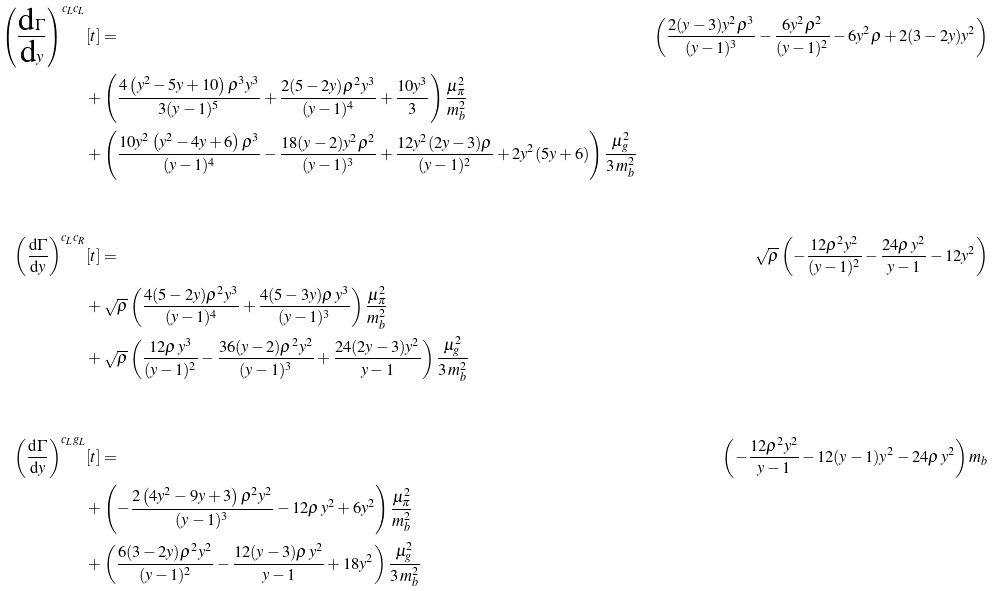Convert formula to latex. <formula><loc_0><loc_0><loc_500><loc_500>\left ( \frac { \text {d} \Gamma } { \text {d} y } \right ) ^ { c _ { L } c _ { L } } & [ t ] = & \left ( \frac { 2 ( y - 3 ) y ^ { 2 } \rho ^ { 3 } } { ( y - 1 ) ^ { 3 } } - \frac { 6 y ^ { 2 } \rho ^ { 2 } } { ( y - 1 ) ^ { 2 } } - 6 y ^ { 2 } \rho + 2 ( 3 - 2 y ) y ^ { 2 } \right ) \\ & + \left ( \frac { 4 \left ( y ^ { 2 } - 5 y + 1 0 \right ) \rho ^ { 3 } y ^ { 3 } } { 3 ( y - 1 ) ^ { 5 } } + \frac { 2 ( 5 - 2 y ) \rho ^ { 2 } y ^ { 3 } } { ( y - 1 ) ^ { 4 } } + \frac { 1 0 y ^ { 3 } } { 3 } \right ) \frac { \mu _ { \pi } ^ { 2 } } { m _ { b } ^ { 2 } } \\ & + \left ( \frac { 1 0 y ^ { 2 } \left ( y ^ { 2 } - 4 y + 6 \right ) \rho ^ { 3 } } { ( y - 1 ) ^ { 4 } } - \frac { 1 8 ( y - 2 ) y ^ { 2 } \rho ^ { 2 } } { ( y - 1 ) ^ { 3 } } + \frac { 1 2 y ^ { 2 } ( 2 y - 3 ) \rho } { ( y - 1 ) ^ { 2 } } + 2 y ^ { 2 } ( 5 y + 6 ) \right ) \frac { \mu _ { g } ^ { 2 } } { 3 \, m _ { b } ^ { 2 } } \\ \\ \left ( \frac { \text {d} \Gamma } { \text {d} y } \right ) ^ { c _ { L } c _ { R } } & [ t ] = & \sqrt { \rho } \left ( - \frac { 1 2 \rho ^ { 2 } y ^ { 2 } } { ( y - 1 ) ^ { 2 } } - \frac { 2 4 \rho \, y ^ { 2 } } { y - 1 } - 1 2 y ^ { 2 } \right ) \\ & + \sqrt { \rho } \left ( \frac { 4 ( 5 - 2 y ) \rho ^ { 2 } y ^ { 3 } } { ( y - 1 ) ^ { 4 } } + \frac { 4 ( 5 - 3 y ) \rho \, y ^ { 3 } } { ( y - 1 ) ^ { 3 } } \right ) \frac { \mu _ { \pi } ^ { 2 } } { m _ { b } ^ { 2 } } \\ & + \sqrt { \rho } \left ( \frac { 1 2 \rho \, y ^ { 3 } } { ( y - 1 ) ^ { 2 } } - \frac { 3 6 ( y - 2 ) \rho ^ { 2 } y ^ { 2 } } { ( y - 1 ) ^ { 3 } } + \frac { 2 4 ( 2 y - 3 ) y ^ { 2 } } { y - 1 } \right ) \frac { \mu _ { g } ^ { 2 } } { 3 \, m _ { b } ^ { 2 } } \\ \\ \left ( \frac { \text {d} \Gamma } { \text {d} y } \right ) ^ { c _ { L } g _ { L } } & [ t ] = & \left ( - \frac { 1 2 \rho ^ { 2 } y ^ { 2 } } { y - 1 } - 1 2 ( y - 1 ) y ^ { 2 } - 2 4 \rho \, y ^ { 2 } \right ) m _ { b } \\ & + \left ( - \frac { 2 \left ( 4 y ^ { 2 } - 9 y + 3 \right ) \rho ^ { 2 } y ^ { 2 } } { ( y - 1 ) ^ { 3 } } - 1 2 \rho \, y ^ { 2 } + 6 y ^ { 2 } \right ) \frac { \mu _ { \pi } ^ { 2 } } { m _ { b } ^ { 2 } } \\ & + \left ( \frac { 6 ( 3 - 2 y ) \rho ^ { 2 } y ^ { 2 } } { ( y - 1 ) ^ { 2 } } - \frac { 1 2 ( y - 3 ) \rho \, y ^ { 2 } } { y - 1 } + 1 8 y ^ { 2 } \right ) \frac { \mu _ { g } ^ { 2 } } { 3 \, m _ { b } ^ { 2 } } \\ \\</formula> 